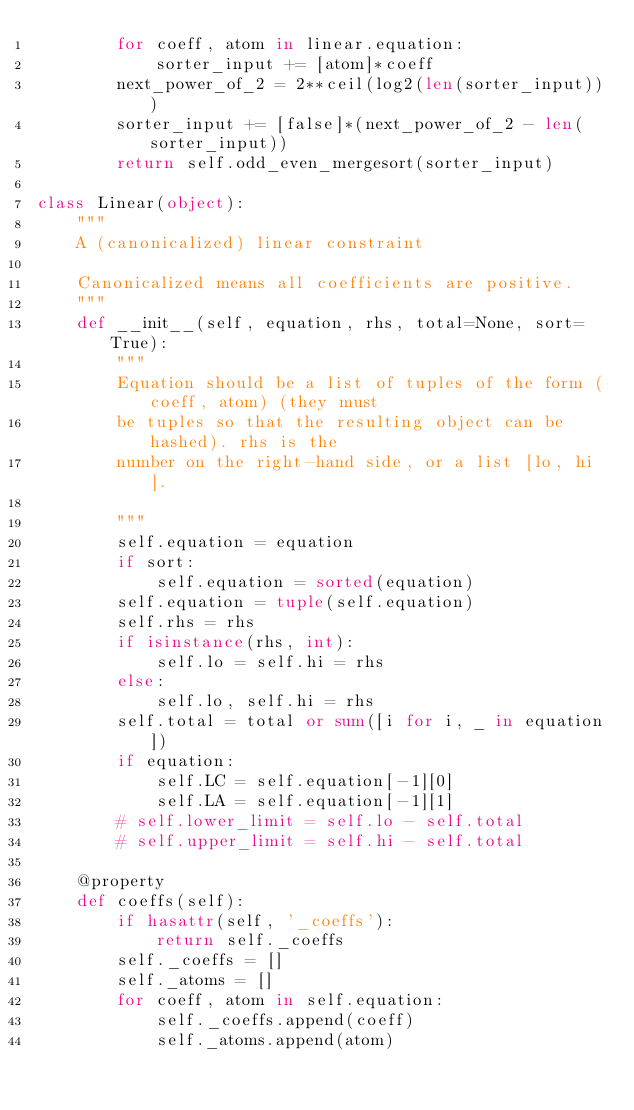Convert code to text. <code><loc_0><loc_0><loc_500><loc_500><_Python_>        for coeff, atom in linear.equation:
            sorter_input += [atom]*coeff
        next_power_of_2 = 2**ceil(log2(len(sorter_input)))
        sorter_input += [false]*(next_power_of_2 - len(sorter_input))
        return self.odd_even_mergesort(sorter_input)

class Linear(object):
    """
    A (canonicalized) linear constraint

    Canonicalized means all coefficients are positive.
    """
    def __init__(self, equation, rhs, total=None, sort=True):
        """
        Equation should be a list of tuples of the form (coeff, atom) (they must
        be tuples so that the resulting object can be hashed). rhs is the
        number on the right-hand side, or a list [lo, hi].

        """
        self.equation = equation
        if sort:
            self.equation = sorted(equation)
        self.equation = tuple(self.equation)
        self.rhs = rhs
        if isinstance(rhs, int):
            self.lo = self.hi = rhs
        else:
            self.lo, self.hi = rhs
        self.total = total or sum([i for i, _ in equation])
        if equation:
            self.LC = self.equation[-1][0]
            self.LA = self.equation[-1][1]
        # self.lower_limit = self.lo - self.total
        # self.upper_limit = self.hi - self.total

    @property
    def coeffs(self):
        if hasattr(self, '_coeffs'):
            return self._coeffs
        self._coeffs = []
        self._atoms = []
        for coeff, atom in self.equation:
            self._coeffs.append(coeff)
            self._atoms.append(atom)</code> 